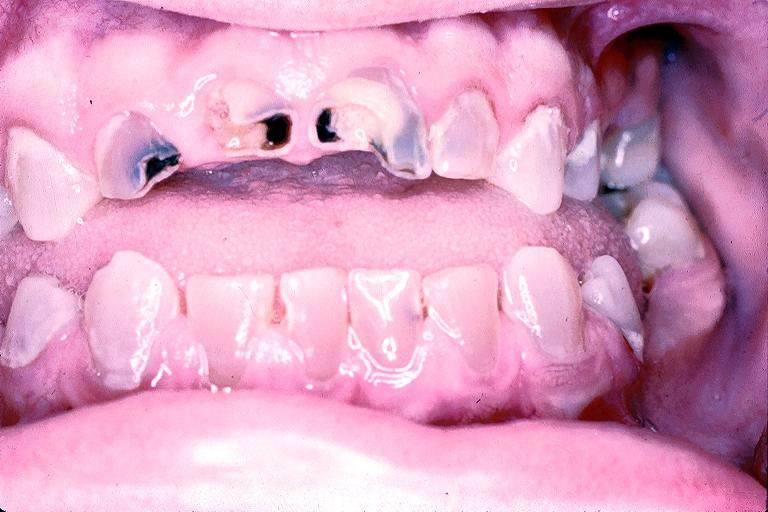s hemorrhagic corpus luteum present?
Answer the question using a single word or phrase. No 